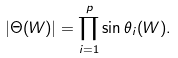Convert formula to latex. <formula><loc_0><loc_0><loc_500><loc_500>| \Theta ( W ) | = \prod _ { i = 1 } ^ { p } \sin \theta _ { i } ( W ) .</formula> 